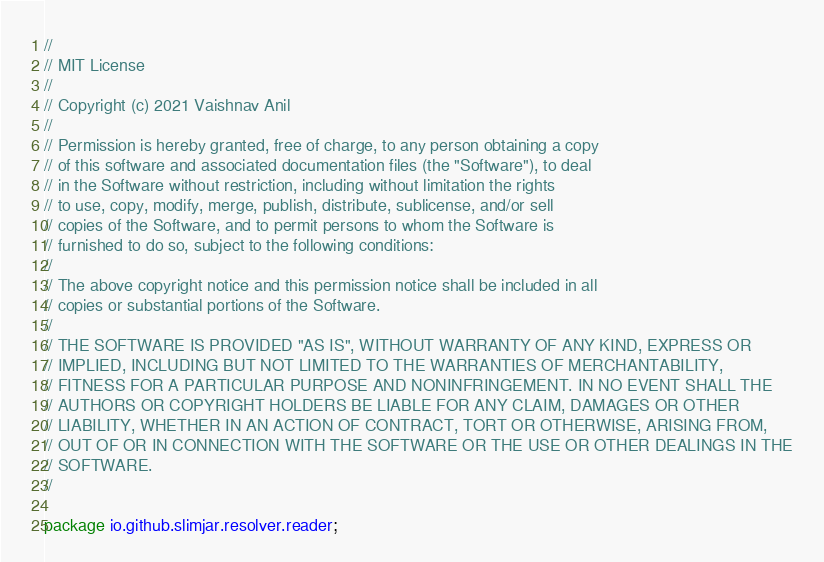Convert code to text. <code><loc_0><loc_0><loc_500><loc_500><_Java_>//
// MIT License
//
// Copyright (c) 2021 Vaishnav Anil
//
// Permission is hereby granted, free of charge, to any person obtaining a copy
// of this software and associated documentation files (the "Software"), to deal
// in the Software without restriction, including without limitation the rights
// to use, copy, modify, merge, publish, distribute, sublicense, and/or sell
// copies of the Software, and to permit persons to whom the Software is
// furnished to do so, subject to the following conditions:
//
// The above copyright notice and this permission notice shall be included in all
// copies or substantial portions of the Software.
//
// THE SOFTWARE IS PROVIDED "AS IS", WITHOUT WARRANTY OF ANY KIND, EXPRESS OR
// IMPLIED, INCLUDING BUT NOT LIMITED TO THE WARRANTIES OF MERCHANTABILITY,
// FITNESS FOR A PARTICULAR PURPOSE AND NONINFRINGEMENT. IN NO EVENT SHALL THE
// AUTHORS OR COPYRIGHT HOLDERS BE LIABLE FOR ANY CLAIM, DAMAGES OR OTHER
// LIABILITY, WHETHER IN AN ACTION OF CONTRACT, TORT OR OTHERWISE, ARISING FROM,
// OUT OF OR IN CONNECTION WITH THE SOFTWARE OR THE USE OR OTHER DEALINGS IN THE
// SOFTWARE.
//

package io.github.slimjar.resolver.reader;

</code> 